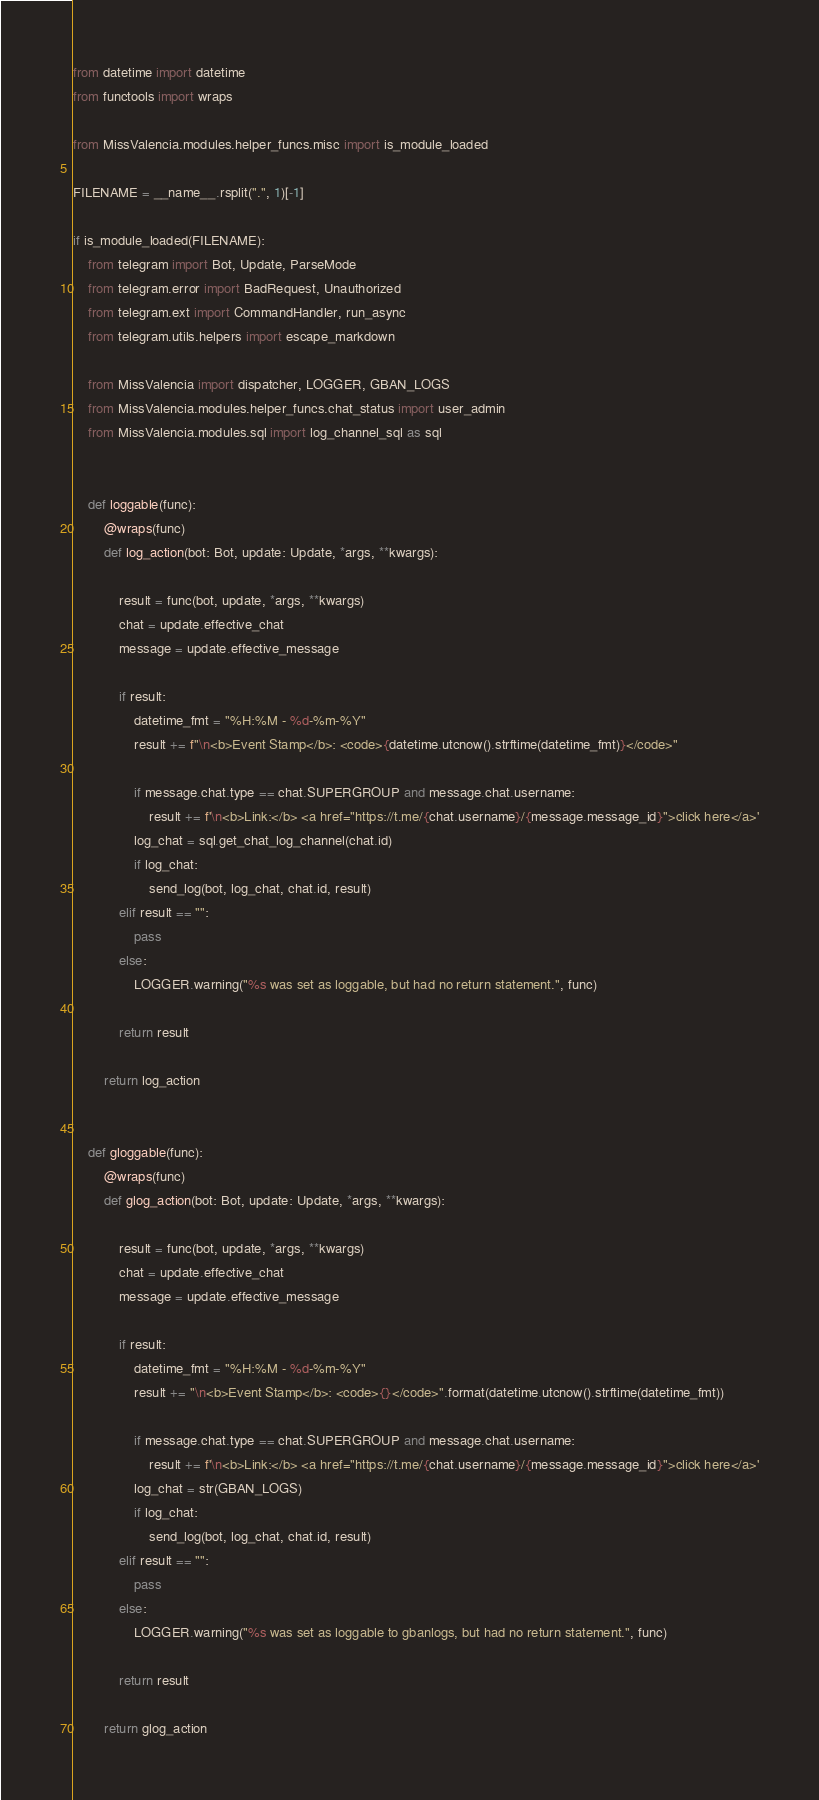Convert code to text. <code><loc_0><loc_0><loc_500><loc_500><_Python_>from datetime import datetime
from functools import wraps

from MissValencia.modules.helper_funcs.misc import is_module_loaded

FILENAME = __name__.rsplit(".", 1)[-1]

if is_module_loaded(FILENAME):
    from telegram import Bot, Update, ParseMode
    from telegram.error import BadRequest, Unauthorized
    from telegram.ext import CommandHandler, run_async
    from telegram.utils.helpers import escape_markdown

    from MissValencia import dispatcher, LOGGER, GBAN_LOGS
    from MissValencia.modules.helper_funcs.chat_status import user_admin
    from MissValencia.modules.sql import log_channel_sql as sql


    def loggable(func):
        @wraps(func)
        def log_action(bot: Bot, update: Update, *args, **kwargs):

            result = func(bot, update, *args, **kwargs)
            chat = update.effective_chat
            message = update.effective_message

            if result:
                datetime_fmt = "%H:%M - %d-%m-%Y"
                result += f"\n<b>Event Stamp</b>: <code>{datetime.utcnow().strftime(datetime_fmt)}</code>"

                if message.chat.type == chat.SUPERGROUP and message.chat.username:
                    result += f'\n<b>Link:</b> <a href="https://t.me/{chat.username}/{message.message_id}">click here</a>'
                log_chat = sql.get_chat_log_channel(chat.id)
                if log_chat:
                    send_log(bot, log_chat, chat.id, result)
            elif result == "":
                pass
            else:
                LOGGER.warning("%s was set as loggable, but had no return statement.", func)

            return result

        return log_action


    def gloggable(func):
        @wraps(func)
        def glog_action(bot: Bot, update: Update, *args, **kwargs):

            result = func(bot, update, *args, **kwargs)
            chat = update.effective_chat
            message = update.effective_message

            if result:
                datetime_fmt = "%H:%M - %d-%m-%Y"
                result += "\n<b>Event Stamp</b>: <code>{}</code>".format(datetime.utcnow().strftime(datetime_fmt))

                if message.chat.type == chat.SUPERGROUP and message.chat.username:
                    result += f'\n<b>Link:</b> <a href="https://t.me/{chat.username}/{message.message_id}">click here</a>'
                log_chat = str(GBAN_LOGS)
                if log_chat:
                    send_log(bot, log_chat, chat.id, result)
            elif result == "":
                pass
            else:
                LOGGER.warning("%s was set as loggable to gbanlogs, but had no return statement.", func)

            return result

        return glog_action

</code> 